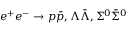Convert formula to latex. <formula><loc_0><loc_0><loc_500><loc_500>e ^ { + } e ^ { - } \to p \bar { p } , \Lambda \bar { \Lambda } , \Sigma ^ { 0 } \bar { \Sigma } ^ { 0 }</formula> 